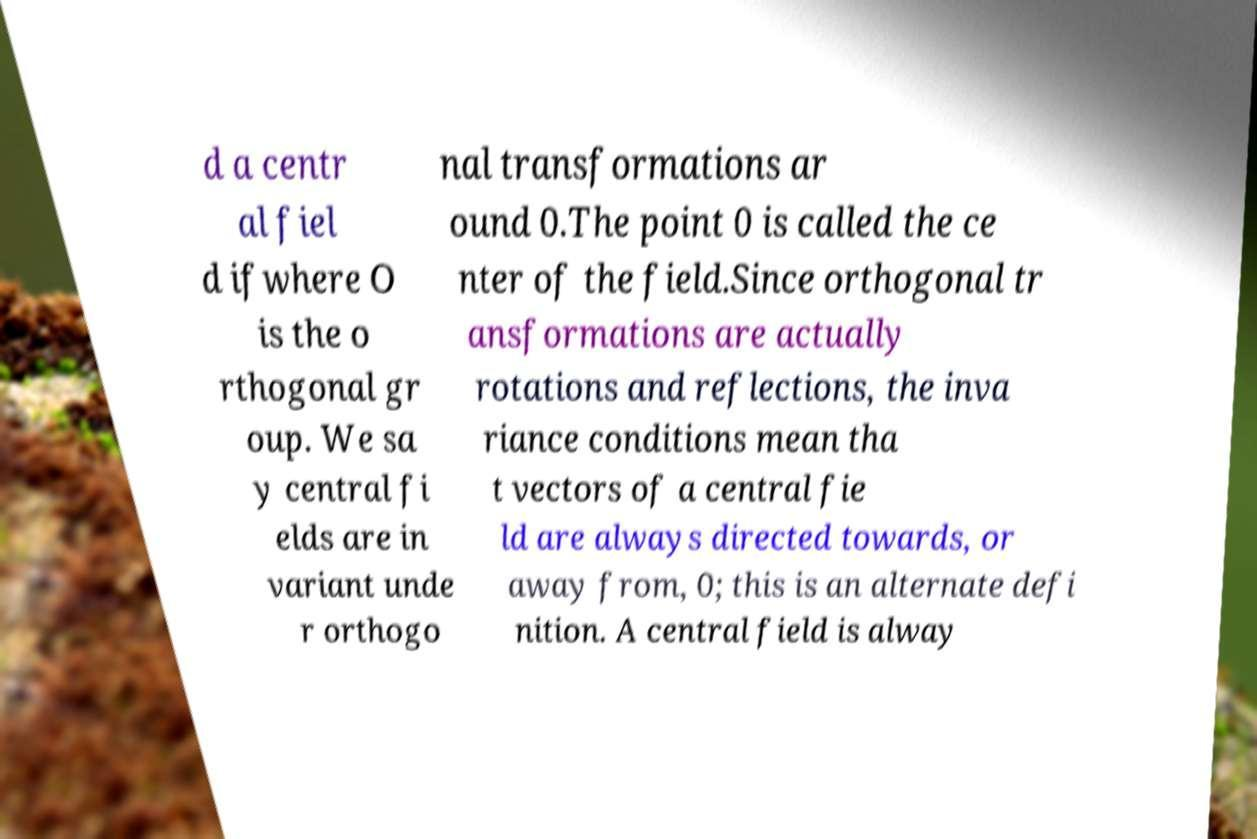Please read and relay the text visible in this image. What does it say? d a centr al fiel d ifwhere O is the o rthogonal gr oup. We sa y central fi elds are in variant unde r orthogo nal transformations ar ound 0.The point 0 is called the ce nter of the field.Since orthogonal tr ansformations are actually rotations and reflections, the inva riance conditions mean tha t vectors of a central fie ld are always directed towards, or away from, 0; this is an alternate defi nition. A central field is alway 